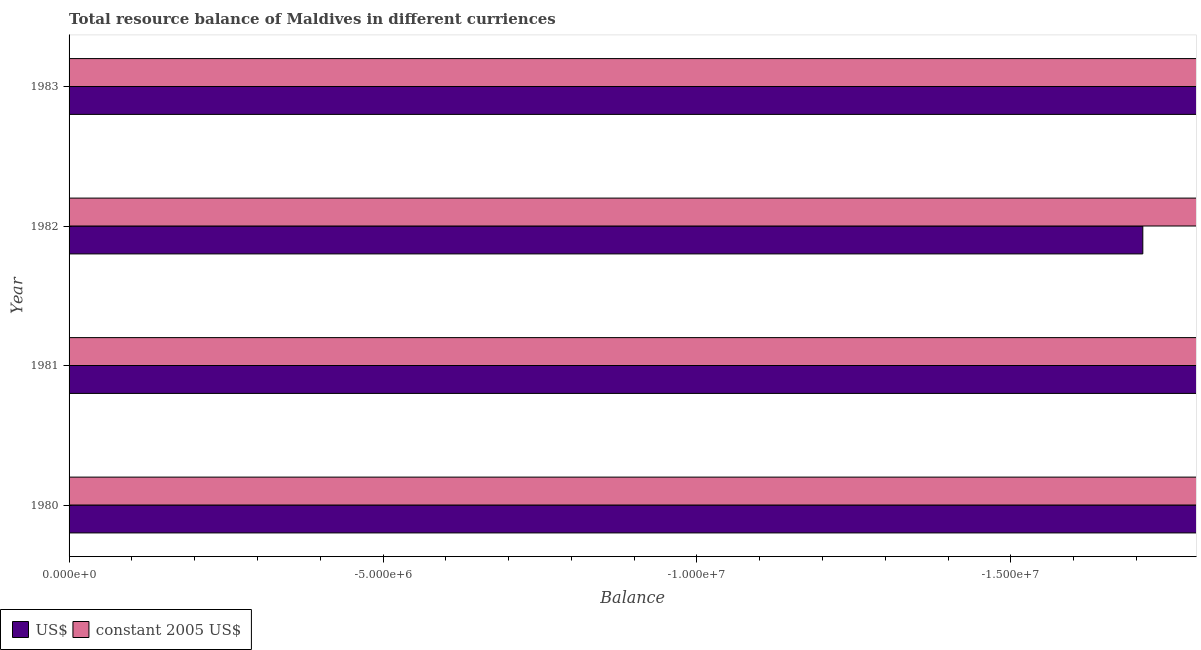Are the number of bars per tick equal to the number of legend labels?
Provide a short and direct response. No. Are the number of bars on each tick of the Y-axis equal?
Your answer should be very brief. Yes. What is the label of the 3rd group of bars from the top?
Your answer should be very brief. 1981. In how many cases, is the number of bars for a given year not equal to the number of legend labels?
Your answer should be very brief. 4. What is the resource balance in us$ in 1981?
Make the answer very short. 0. Across all years, what is the minimum resource balance in us$?
Offer a terse response. 0. What is the total resource balance in constant us$ in the graph?
Provide a succinct answer. 0. What is the difference between the resource balance in constant us$ in 1983 and the resource balance in us$ in 1981?
Ensure brevity in your answer.  0. In how many years, is the resource balance in constant us$ greater than -5000000 units?
Ensure brevity in your answer.  0. In how many years, is the resource balance in us$ greater than the average resource balance in us$ taken over all years?
Provide a short and direct response. 0. Are all the bars in the graph horizontal?
Give a very brief answer. Yes. How many years are there in the graph?
Your answer should be very brief. 4. Does the graph contain any zero values?
Give a very brief answer. Yes. How many legend labels are there?
Give a very brief answer. 2. What is the title of the graph?
Make the answer very short. Total resource balance of Maldives in different curriences. Does "Services" appear as one of the legend labels in the graph?
Offer a terse response. No. What is the label or title of the X-axis?
Keep it short and to the point. Balance. What is the label or title of the Y-axis?
Give a very brief answer. Year. What is the Balance of constant 2005 US$ in 1980?
Offer a very short reply. 0. What is the Balance of US$ in 1981?
Provide a short and direct response. 0. What is the Balance in constant 2005 US$ in 1981?
Your answer should be compact. 0. What is the Balance in US$ in 1982?
Provide a succinct answer. 0. What is the Balance of constant 2005 US$ in 1982?
Your response must be concise. 0. What is the Balance in constant 2005 US$ in 1983?
Keep it short and to the point. 0. What is the total Balance in US$ in the graph?
Ensure brevity in your answer.  0. What is the average Balance of constant 2005 US$ per year?
Keep it short and to the point. 0. 